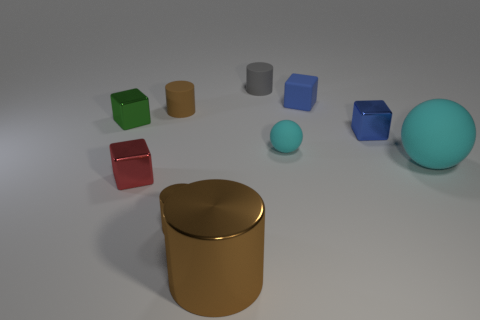How many brown cylinders must be subtracted to get 1 brown cylinders? 2 Subtract all cyan cubes. How many brown cylinders are left? 3 Subtract all rubber cubes. How many cubes are left? 3 Subtract all blocks. How many objects are left? 6 Subtract 2 cyan balls. How many objects are left? 8 Subtract all large cyan spheres. Subtract all small gray objects. How many objects are left? 8 Add 9 green cubes. How many green cubes are left? 10 Add 9 big blue shiny blocks. How many big blue shiny blocks exist? 9 